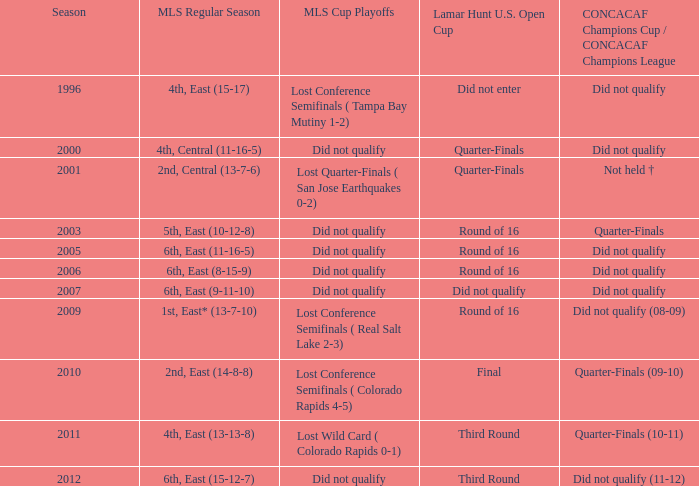What occurred in the mls cup playoffs during the concacaf champions cup/concacaf champions league quarter-finals (09-10)? Lost Conference Semifinals ( Colorado Rapids 4-5). 